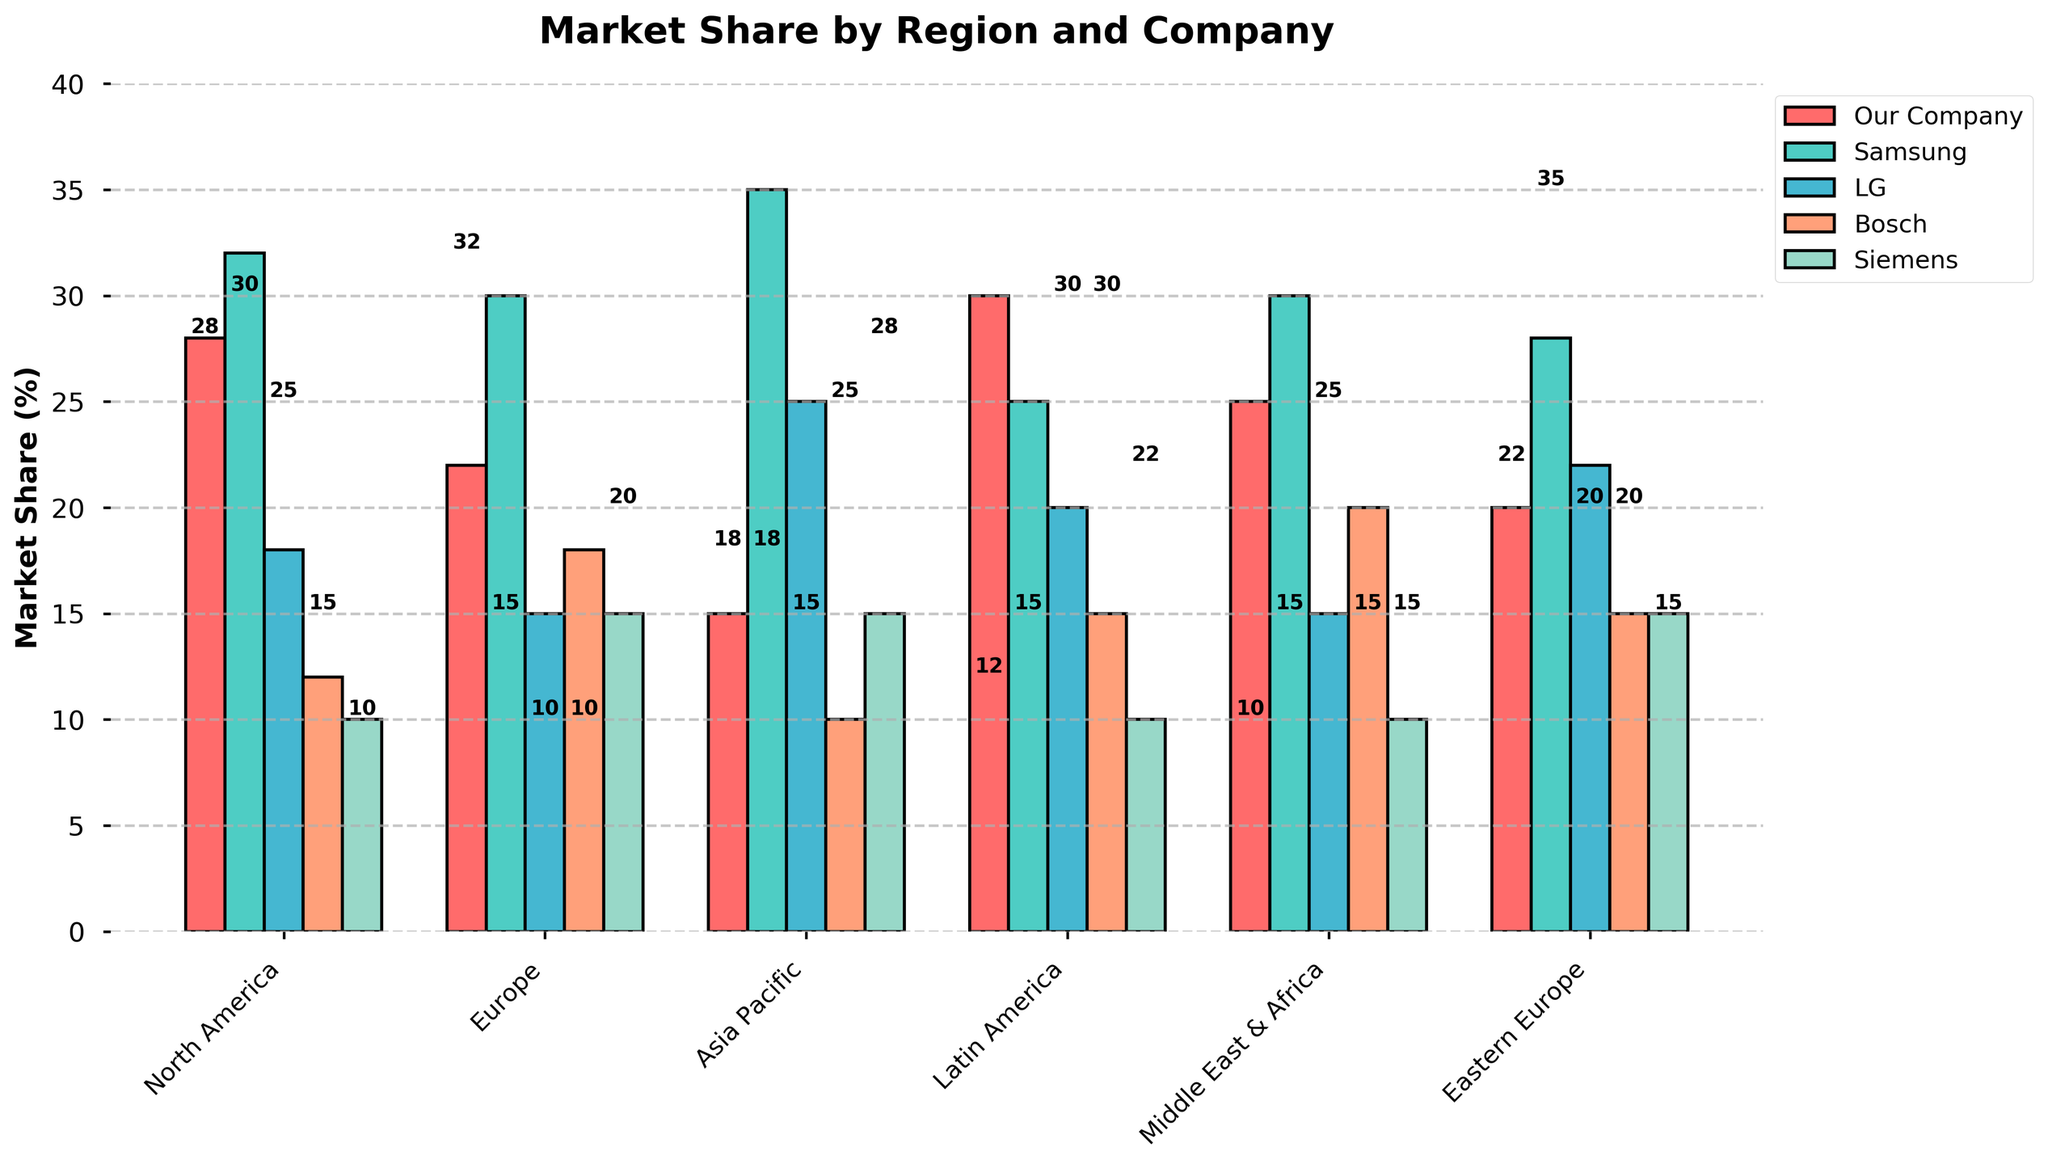Which company has the highest market share in North America? Compare the values of market shares in North America for all companies. Samsung has the highest (32%).
Answer: Samsung What's the difference between Our Company's market share in North America and Europe? Subtract Our Company's market share in Europe (22%) from North America (28%): 28% - 22% = 6%.
Answer: 6% In which region does LG have the largest market share? Look at LG's market share across all regions and identify the highest value. LG has the largest share in Asia Pacific (25%).
Answer: Asia Pacific Compare Bosch’s market share in Middle East & Africa and Latin America. In which region is it higher? Compare Bosch’s market share in Middle East & Africa (20%) with that in Latin America (15%). It is higher in Middle East & Africa.
Answer: Middle East & Africa What's the average market share of Siemens across all regions? Sum Siemens' market shares across all regions (10 + 15 + 15 + 10 + 10 + 15 = 75) and divide by the number of regions (6): 75 / 6 ≈ 12.5%.
Answer: 12.5% What is the total market share for all companies in Eastern Europe? Sum up the market shares of all companies in Eastern Europe (20 + 28 + 22 + 15 + 15): 20 + 28 + 22 + 15 + 15 = 100%.
Answer: 100% Which company has the smallest market share in Asia Pacific? Identify the smallest value of market shares in Asia Pacific among all companies: Bosch and Siemens both have the smallest shares (10%).
Answer: Bosch and Siemens Is our company’s market share higher in Latin America or Middle East & Africa? Compare our company's market share in Latin America (30%) with Middle East & Africa (25%). It is higher in Latin America.
Answer: Latin America How much higher is Samsung’s market share than Our Company’s in Europe? Subtract Our Company's market share in Europe (22%) from Samsung's (30%): 30% - 22% = 8%.
Answer: 8% Which region shows the highest total market share for all competitors combined? Calculate the total market share for all competitors (Samsung, LG, Bosch, Siemens) in each region and identify the highest value: North America (32+18+12+10=72%), Europe (30+15+18+15=78%), Asia Pacific (35+25+10+15=85%), Latin America (25+20+15+10=70%), Middle East & Africa (30+15+20+10=75%), Eastern Europe (28+22+15+15=80%). The highest combined market share for competitors is in Asia Pacific (85%).
Answer: Asia Pacific 